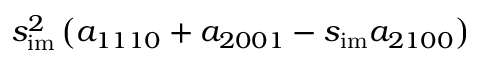<formula> <loc_0><loc_0><loc_500><loc_500>s _ { i m } ^ { 2 } \left ( a _ { 1 1 1 0 } + a _ { 2 0 0 1 } - s _ { i m } a _ { 2 1 0 0 } \right )</formula> 